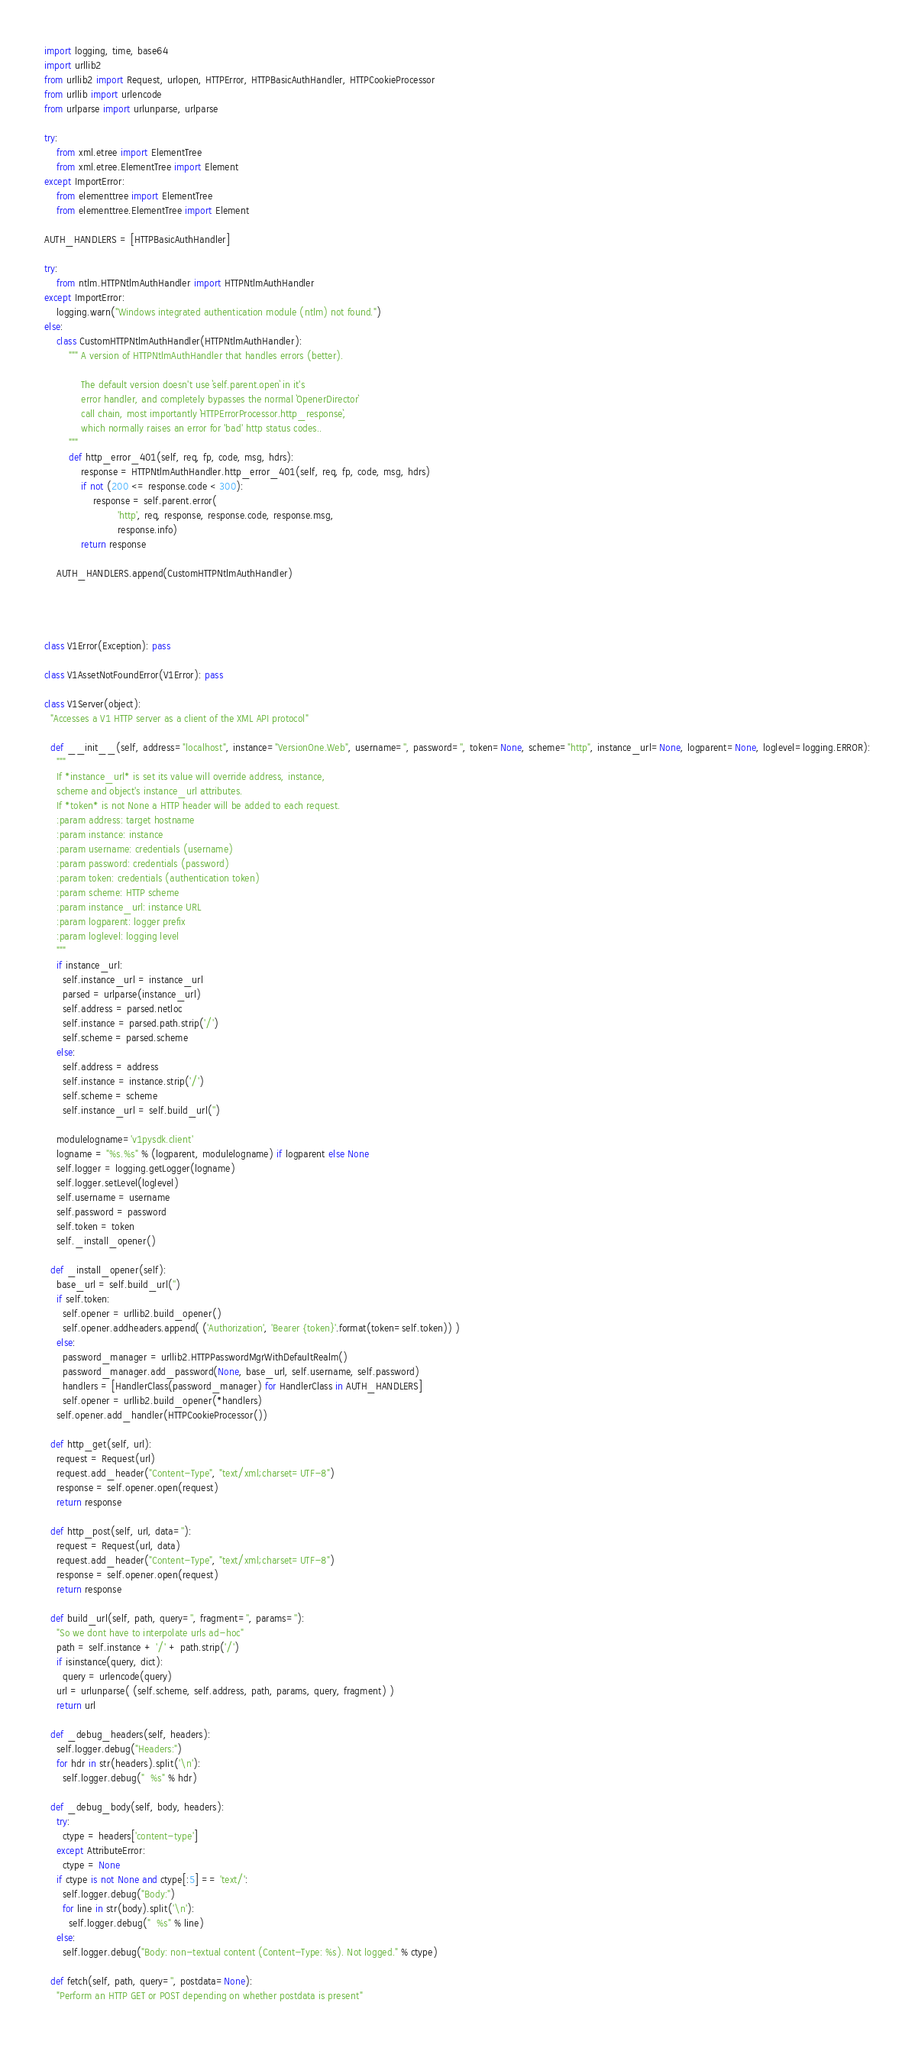<code> <loc_0><loc_0><loc_500><loc_500><_Python_>
import logging, time, base64
import urllib2
from urllib2 import Request, urlopen, HTTPError, HTTPBasicAuthHandler, HTTPCookieProcessor
from urllib import urlencode
from urlparse import urlunparse, urlparse

try:
    from xml.etree import ElementTree
    from xml.etree.ElementTree import Element
except ImportError:
    from elementtree import ElementTree
    from elementtree.ElementTree import Element

AUTH_HANDLERS = [HTTPBasicAuthHandler]

try:
    from ntlm.HTTPNtlmAuthHandler import HTTPNtlmAuthHandler
except ImportError:
    logging.warn("Windows integrated authentication module (ntlm) not found.")
else:
    class CustomHTTPNtlmAuthHandler(HTTPNtlmAuthHandler):
        """ A version of HTTPNtlmAuthHandler that handles errors (better).

            The default version doesn't use `self.parent.open` in it's
            error handler, and completely bypasses the normal `OpenerDirector`
            call chain, most importantly `HTTPErrorProcessor.http_response`,
            which normally raises an error for 'bad' http status codes..
        """
        def http_error_401(self, req, fp, code, msg, hdrs):
            response = HTTPNtlmAuthHandler.http_error_401(self, req, fp, code, msg, hdrs)
            if not (200 <= response.code < 300):
                response = self.parent.error(
                        'http', req, response, response.code, response.msg,
                        response.info)
            return response

    AUTH_HANDLERS.append(CustomHTTPNtlmAuthHandler)




class V1Error(Exception): pass

class V1AssetNotFoundError(V1Error): pass

class V1Server(object):
  "Accesses a V1 HTTP server as a client of the XML API protocol"

  def __init__(self, address="localhost", instance="VersionOne.Web", username='', password='', token=None, scheme="http", instance_url=None, logparent=None, loglevel=logging.ERROR):
    """
    If *instance_url* is set its value will override address, instance,
    scheme and object's instance_url attributes.
    If *token* is not None a HTTP header will be added to each request.
    :param address: target hostname
    :param instance: instance
    :param username: credentials (username)
    :param password: credentials (password)
    :param token: credentials (authentication token)
    :param scheme: HTTP scheme
    :param instance_url: instance URL
    :param logparent: logger prefix
    :param loglevel: logging level
    """
    if instance_url:
      self.instance_url = instance_url
      parsed = urlparse(instance_url)
      self.address = parsed.netloc
      self.instance = parsed.path.strip('/')
      self.scheme = parsed.scheme
    else:
      self.address = address
      self.instance = instance.strip('/')
      self.scheme = scheme
      self.instance_url = self.build_url('')

    modulelogname='v1pysdk.client'
    logname = "%s.%s" % (logparent, modulelogname) if logparent else None
    self.logger = logging.getLogger(logname)
    self.logger.setLevel(loglevel)
    self.username = username
    self.password = password
    self.token = token
    self._install_opener()
        
  def _install_opener(self):
    base_url = self.build_url('')
    if self.token:
      self.opener = urllib2.build_opener()
      self.opener.addheaders.append( ('Authorization', 'Bearer {token}'.format(token=self.token)) )
    else:
      password_manager = urllib2.HTTPPasswordMgrWithDefaultRealm()
      password_manager.add_password(None, base_url, self.username, self.password)
      handlers = [HandlerClass(password_manager) for HandlerClass in AUTH_HANDLERS]
      self.opener = urllib2.build_opener(*handlers)
    self.opener.add_handler(HTTPCookieProcessor())

  def http_get(self, url):
    request = Request(url)
    request.add_header("Content-Type", "text/xml;charset=UTF-8")
    response = self.opener.open(request)
    return response
  
  def http_post(self, url, data=''):
    request = Request(url, data)
    request.add_header("Content-Type", "text/xml;charset=UTF-8")
    response = self.opener.open(request)
    return response
    
  def build_url(self, path, query='', fragment='', params=''):
    "So we dont have to interpolate urls ad-hoc"
    path = self.instance + '/' + path.strip('/')
    if isinstance(query, dict):
      query = urlencode(query)
    url = urlunparse( (self.scheme, self.address, path, params, query, fragment) )
    return url

  def _debug_headers(self, headers):
    self.logger.debug("Headers:")
    for hdr in str(headers).split('\n'):
      self.logger.debug("  %s" % hdr)

  def _debug_body(self, body, headers):
    try:
      ctype = headers['content-type']
    except AttributeError:
      ctype = None
    if ctype is not None and ctype[:5] == 'text/':
      self.logger.debug("Body:")
      for line in str(body).split('\n'):
        self.logger.debug("  %s" % line)
    else:
      self.logger.debug("Body: non-textual content (Content-Type: %s). Not logged." % ctype)

  def fetch(self, path, query='', postdata=None):
    "Perform an HTTP GET or POST depending on whether postdata is present"</code> 